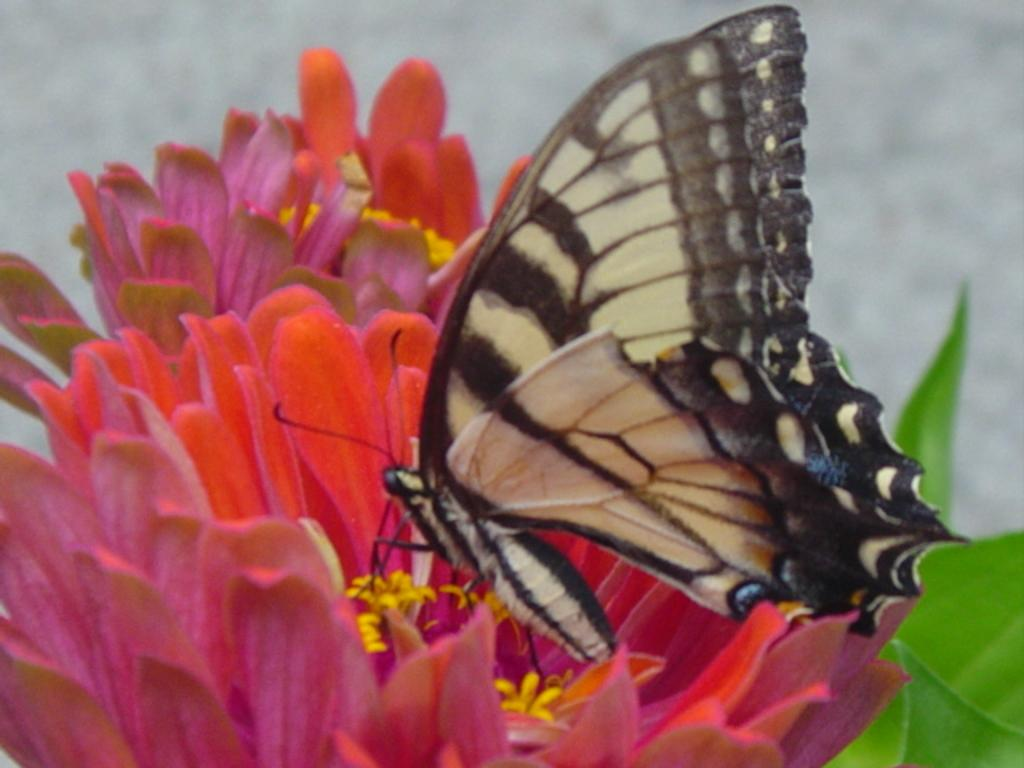What type of creature can be seen in the image? There is a butterfly in the image. What other natural elements are present in the image? There are flowers and leaves in the image. Can you describe the background of the image? The background of the image is blurred. What type of acoustics can be heard in the image? There is no sound or acoustics present in the image, as it is a still photograph. 